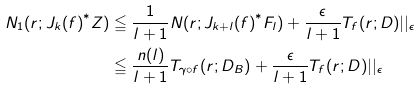<formula> <loc_0><loc_0><loc_500><loc_500>N _ { 1 } ( r ; { J _ { k } ( f ) } ^ { * } { Z } ) & \leqq \frac { 1 } { l + 1 } N ( r ; { J _ { k + l } ( f ) } ^ { * } { F _ { l } } ) + \frac { \epsilon } { l + 1 } T _ { f } ( r ; { D } ) | | _ { \epsilon } \\ & \leqq \frac { n ( l ) } { l + 1 } T _ { \gamma \circ f } ( r ; { D _ { B } } ) + \frac { \epsilon } { l + 1 } T _ { f } ( r ; { D } ) | | _ { \epsilon }</formula> 